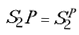Convert formula to latex. <formula><loc_0><loc_0><loc_500><loc_500>S _ { 2 } P = S _ { 2 } ^ { P }</formula> 